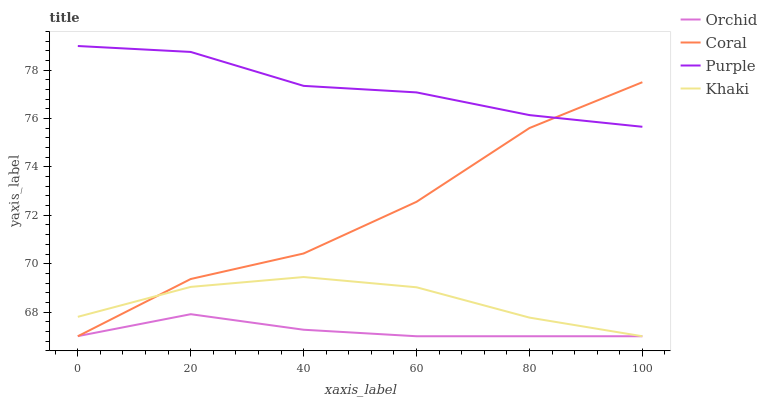Does Orchid have the minimum area under the curve?
Answer yes or no. Yes. Does Purple have the maximum area under the curve?
Answer yes or no. Yes. Does Coral have the minimum area under the curve?
Answer yes or no. No. Does Coral have the maximum area under the curve?
Answer yes or no. No. Is Orchid the smoothest?
Answer yes or no. Yes. Is Coral the roughest?
Answer yes or no. Yes. Is Khaki the smoothest?
Answer yes or no. No. Is Khaki the roughest?
Answer yes or no. No. Does Coral have the lowest value?
Answer yes or no. Yes. Does Purple have the highest value?
Answer yes or no. Yes. Does Coral have the highest value?
Answer yes or no. No. Is Khaki less than Purple?
Answer yes or no. Yes. Is Purple greater than Orchid?
Answer yes or no. Yes. Does Coral intersect Purple?
Answer yes or no. Yes. Is Coral less than Purple?
Answer yes or no. No. Is Coral greater than Purple?
Answer yes or no. No. Does Khaki intersect Purple?
Answer yes or no. No. 